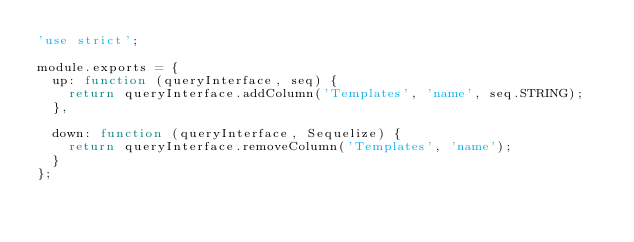Convert code to text. <code><loc_0><loc_0><loc_500><loc_500><_JavaScript_>'use strict';

module.exports = {
  up: function (queryInterface, seq) {
    return queryInterface.addColumn('Templates', 'name', seq.STRING);
  },

  down: function (queryInterface, Sequelize) {
    return queryInterface.removeColumn('Templates', 'name');
  }
};
</code> 